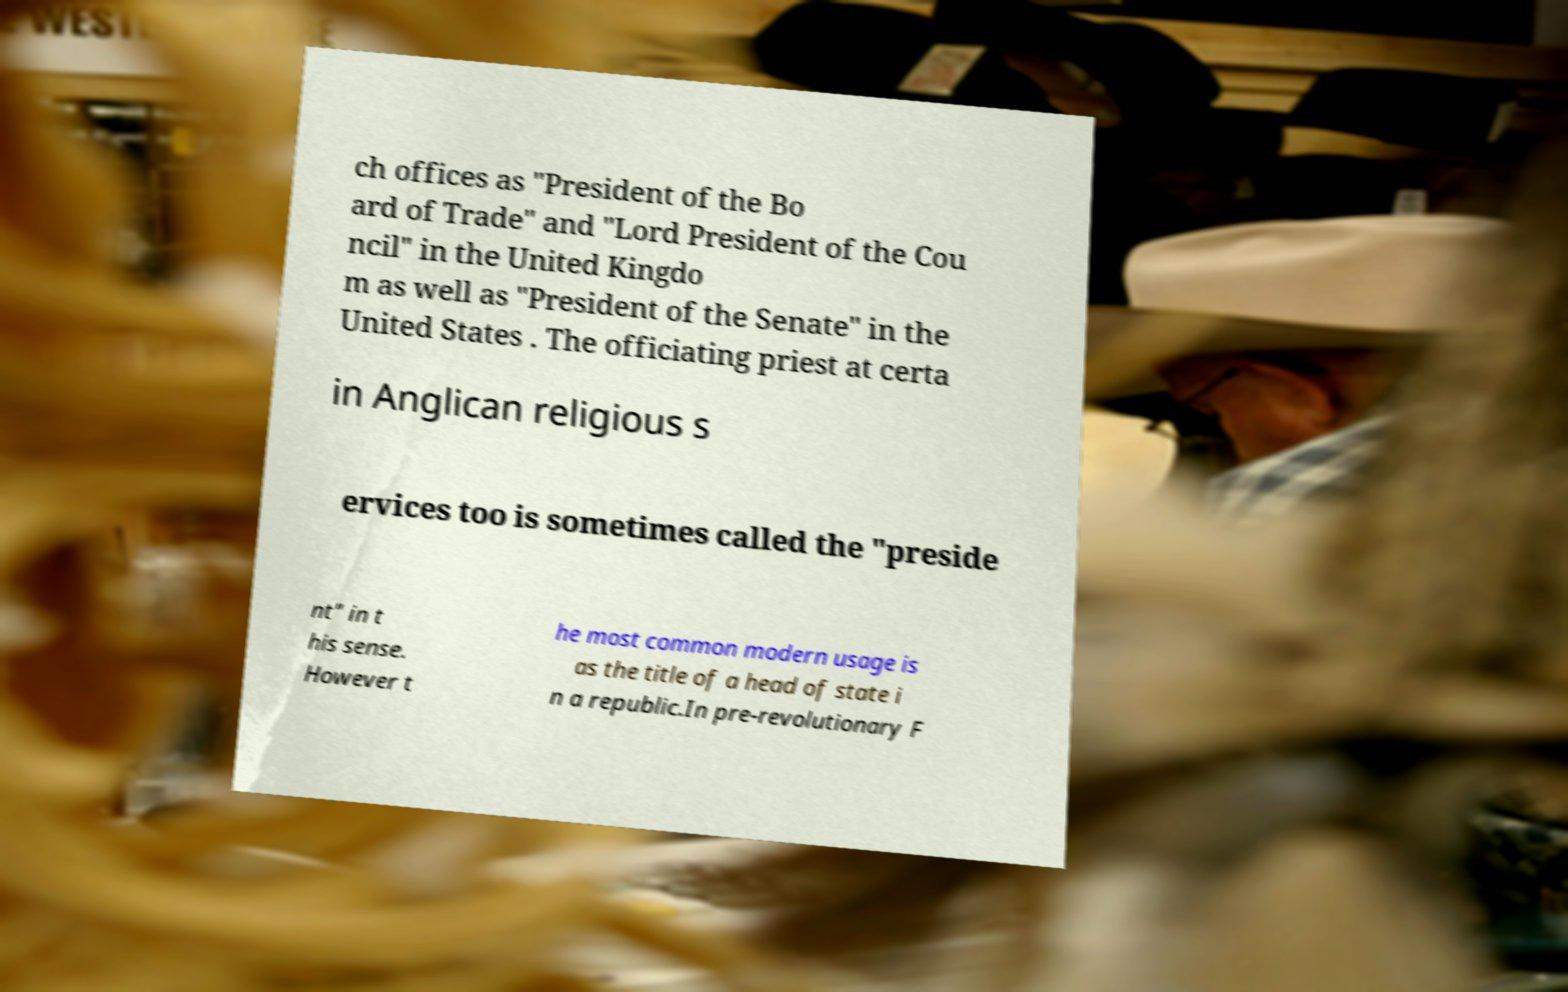Please identify and transcribe the text found in this image. ch offices as "President of the Bo ard of Trade" and "Lord President of the Cou ncil" in the United Kingdo m as well as "President of the Senate" in the United States . The officiating priest at certa in Anglican religious s ervices too is sometimes called the "preside nt" in t his sense. However t he most common modern usage is as the title of a head of state i n a republic.In pre-revolutionary F 